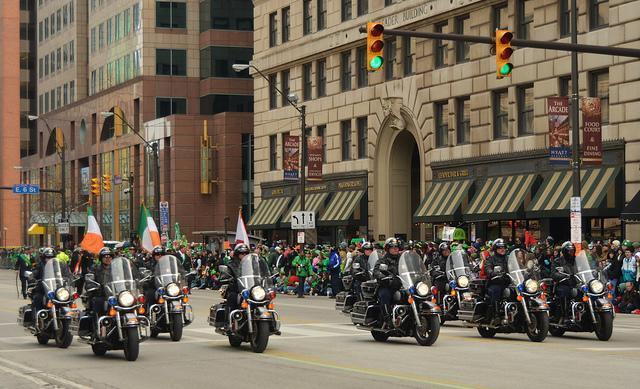How many motorcycles on the street?
Give a very brief answer. 9. How many motorcycles can be seen?
Give a very brief answer. 8. How many suitcases are there?
Give a very brief answer. 0. 